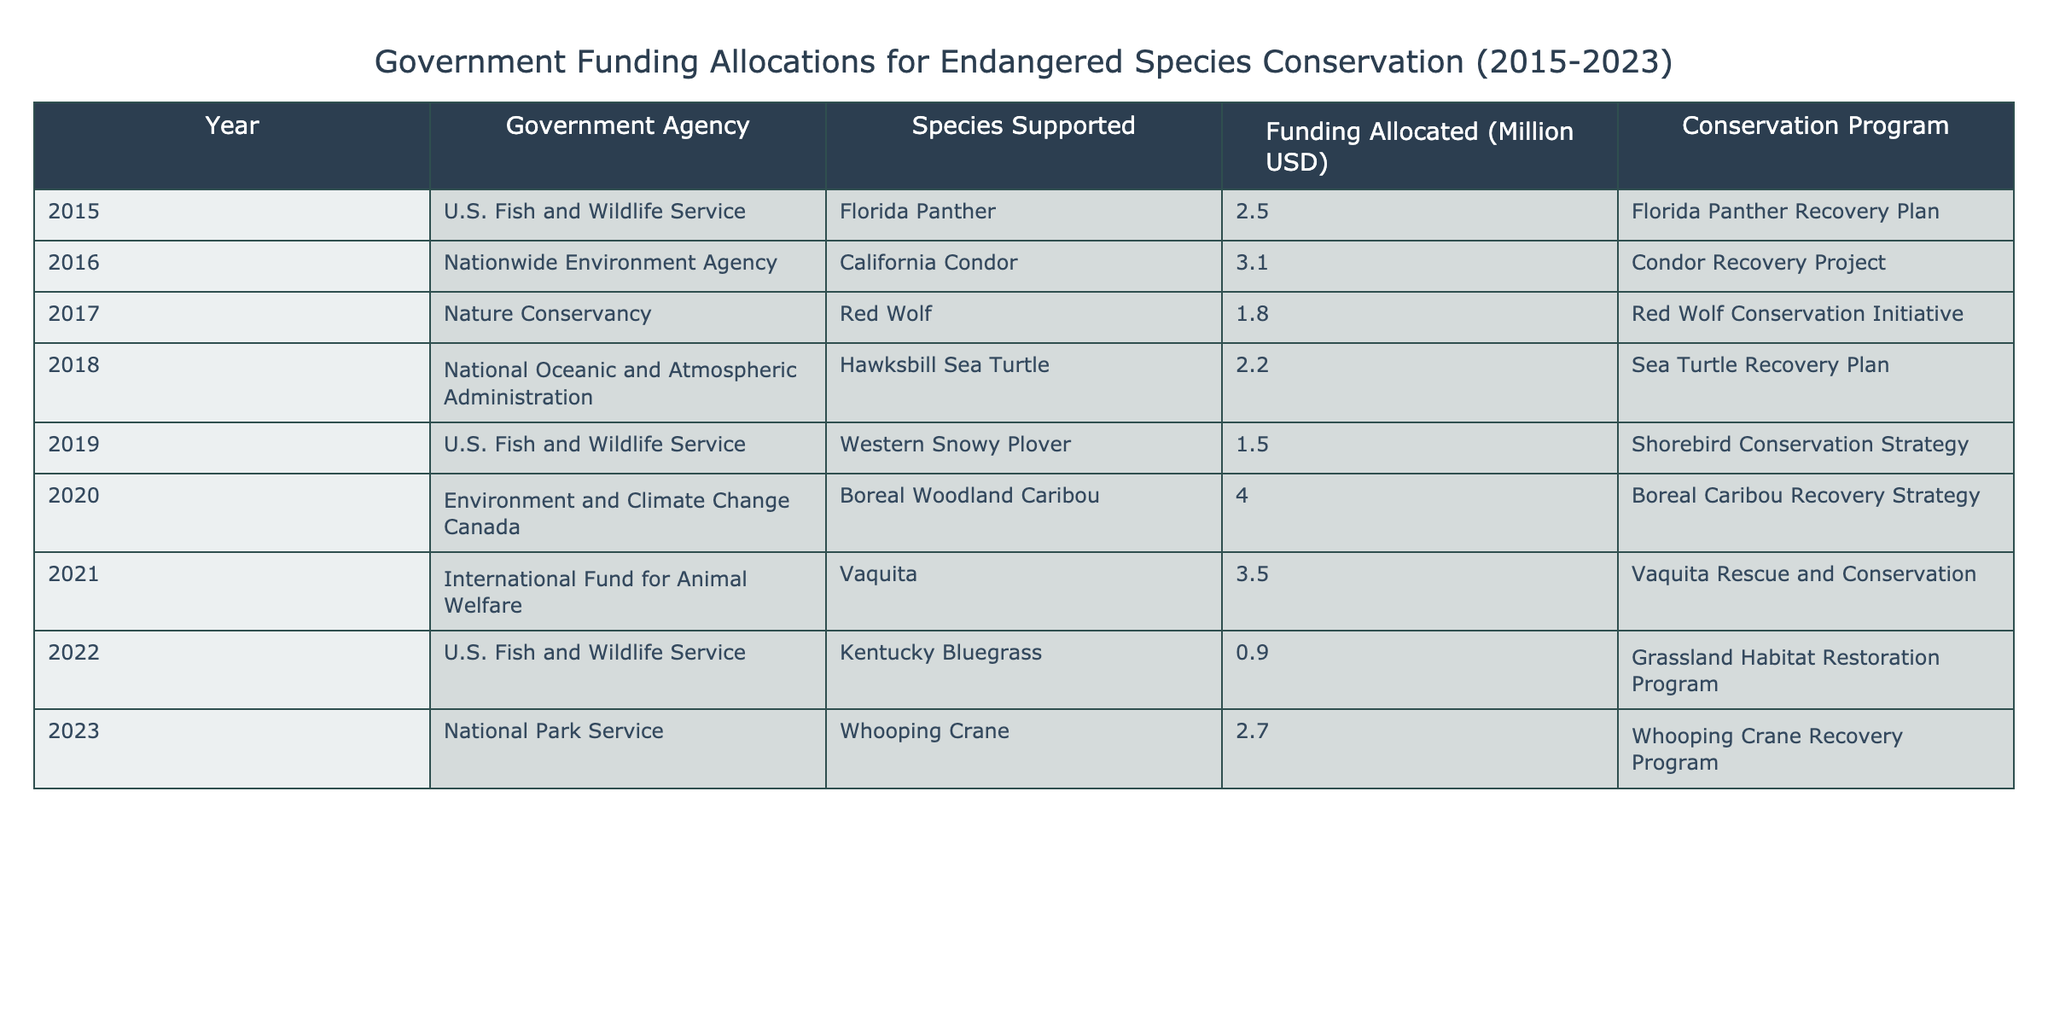What was the funding allocated for the California Condor in 2016? The table shows that in 2016, the funding allocated for the California Condor was 3.1 million USD.
Answer: 3.1 million USD Which species received the highest funding in 2020? According to the table, the Boreal Woodland Caribou received the highest funding in 2020, which was 4.0 million USD.
Answer: Boreal Woodland Caribou What is the total funding allocated for endangered species in 2015 and 2021? The funding allocated in 2015 was 2.5 million USD and in 2021 it was 3.5 million USD. Adding these together gives a total of 2.5 + 3.5 = 6.0 million USD.
Answer: 6.0 million USD Did the U.S. Fish and Wildlife Service support any species in 2022? The table indicates that the U.S. Fish and Wildlife Service did support a species in 2022, specifically the Kentucky Bluegrass.
Answer: Yes What is the average funding allocated per year from 2015 to 2023? First, we gather the funding amounts: 2.5, 3.1, 1.8, 2.2, 1.5, 4.0, 3.5, 0.9, and 2.7 million USD. Adding them gives a total of 20.7 million USD. There are 9 years in total, so the average is 20.7 / 9 ≈ 2.3 million USD.
Answer: Approximately 2.3 million USD Which conservation program received the lowest funding? The table indicates that the Grassland Habitat Restoration Program received the lowest funding of 0.9 million USD in 2022.
Answer: Grassland Habitat Restoration Program How many different government agencies supported endangered species from 2015 to 2023? By looking at the table, we see that there are 6 different government agencies listed: U.S. Fish and Wildlife Service, Nationwide Environment Agency, Nature Conservancy, National Oceanic and Atmospheric Administration, Environment and Climate Change Canada, and International Fund for Animal Welfare, which totals to 6.
Answer: 6 What was the total funding for the Red Wolf Conservation Initiative and the Vaquita Rescue and Conservation combined? The funding for the Red Wolf Conservation Initiative in 2017 was 1.8 million USD, and for the Vaquita Rescue and Conservation in 2021 was 3.5 million USD. Adding these amounts together results in 1.8 + 3.5 = 5.3 million USD.
Answer: 5.3 million USD 